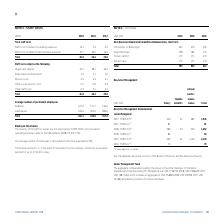According to Torm's financial document, What are the staff costs included in operating expenses related to? the 108 seafarers (2018: 112, 2017: 131).. The document states: "aff costs included in operating expenses relate to the 108 seafarers (2018: 112, 2017: 131). The average number of employees is calculated as a full-t..." Also, How is the average number of employees calculated? as a full-time equivalent (FTE). The document states: "31). The average number of employees is calculated as a full-time equivalent (FTE). The Executive Director is, in the event of termination by the Comp..." Also, What do the staff costs comprise of? The document contains multiple relevant values: Wages and salaries, Share-based compensation, Pension costs, Other social security costs, Other staff costs. From the document: "Pension costs 3.5 3.3 3.1 Wages and salaries 37.2 38.1 36.4 Share-based compensation 1.9 2.1 1.9 Other social security costs 0.9 0.6 0.3 Other staff c..." Additionally, In which year was the pension costs the largest? According to the financial document, 2019. The relevant text states: "USDm 2019 2018 2017..." Also, can you calculate: What was the change in the total number of permanent employees from 2018 to 2019? Based on the calculation: 421.1-413.9, the result is 7.2 (in millions). This is based on the information: "Total 421.1 413.9 417.2 Total 421.1 413.9 417.2..." The key data points involved are: 413.9, 421.1. Also, can you calculate: What was the percentage change in the total number of permanent employees from 2018 to 2019? To answer this question, I need to perform calculations using the financial data. The calculation is: (421.1-413.9)/413.9, which equals 1.74 (percentage). This is based on the information: "Total 421.1 413.9 417.2 Total 421.1 413.9 417.2..." The key data points involved are: 413.9, 421.1. 